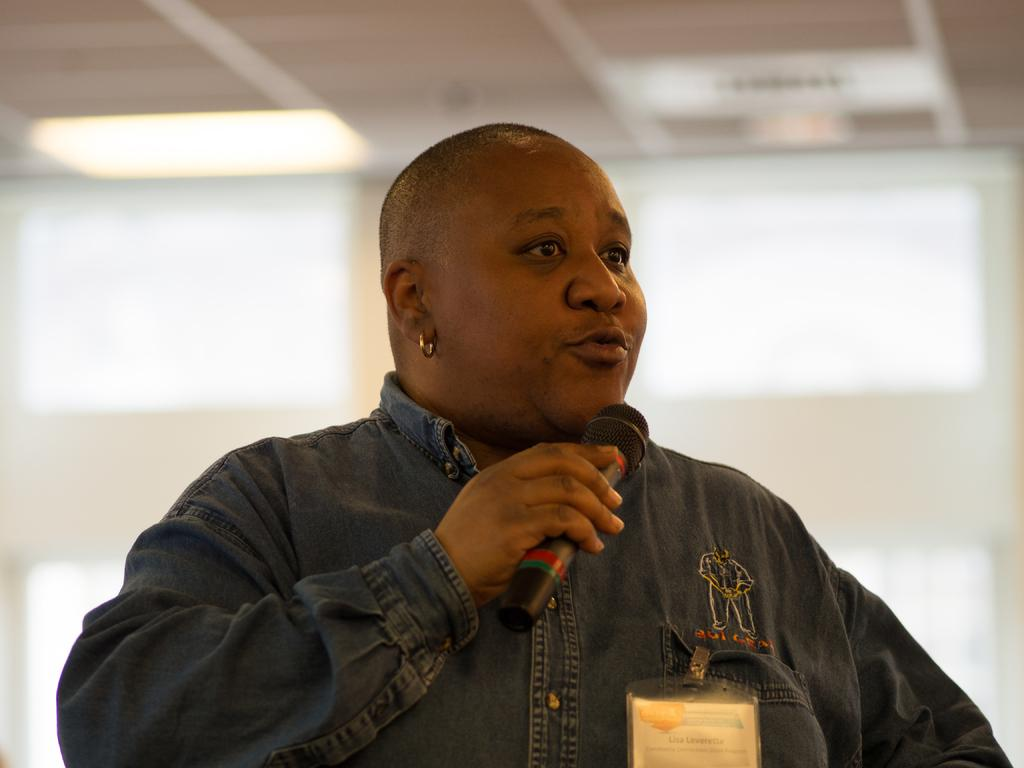What is the main subject of the image? The main subject of the image is a man. What is the man doing in the image? The man is standing and talking in the image. What is the man holding in his hand? The man is holding a microphone in his hand. What can be seen attached to the man's shirt? There is a badge attached to the man's shirt. Can you see the ocean in the background of the image? There is no ocean visible in the image; it is focused on the man and his actions. 